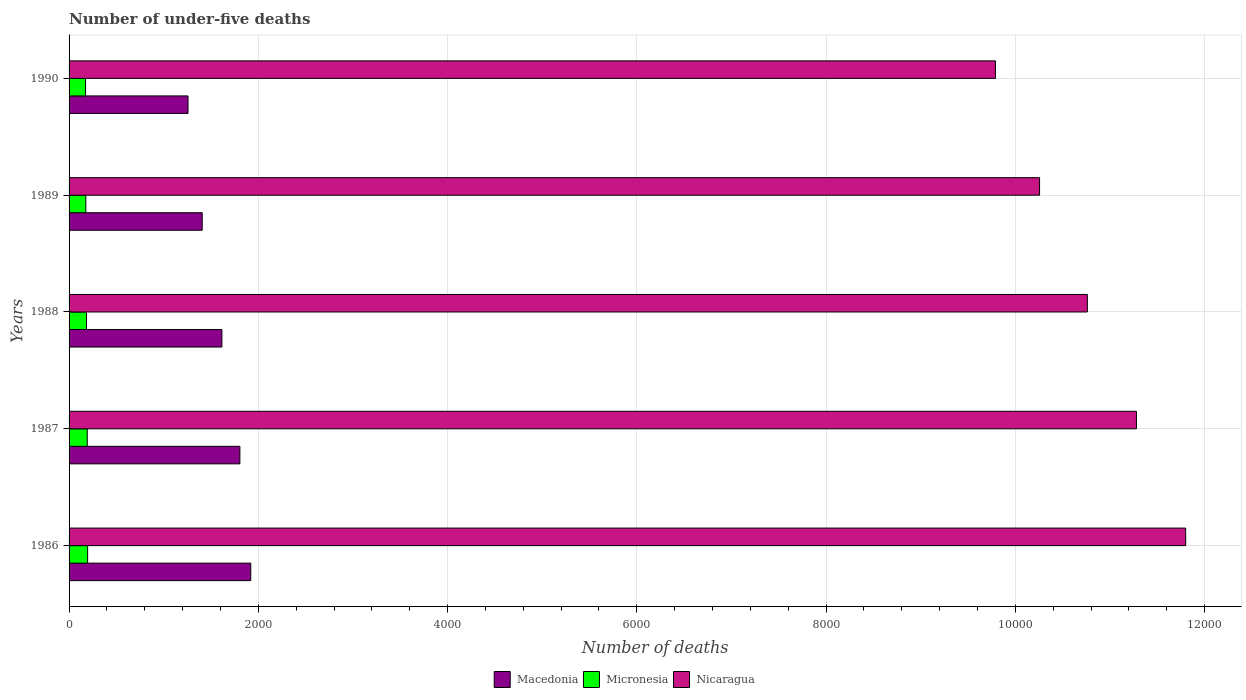How many different coloured bars are there?
Offer a terse response. 3. How many groups of bars are there?
Give a very brief answer. 5. Are the number of bars per tick equal to the number of legend labels?
Provide a succinct answer. Yes. Are the number of bars on each tick of the Y-axis equal?
Offer a terse response. Yes. What is the label of the 4th group of bars from the top?
Your answer should be very brief. 1987. What is the number of under-five deaths in Micronesia in 1986?
Your answer should be compact. 196. Across all years, what is the maximum number of under-five deaths in Nicaragua?
Make the answer very short. 1.18e+04. Across all years, what is the minimum number of under-five deaths in Micronesia?
Offer a terse response. 174. In which year was the number of under-five deaths in Macedonia maximum?
Your answer should be very brief. 1986. What is the total number of under-five deaths in Nicaragua in the graph?
Give a very brief answer. 5.39e+04. What is the difference between the number of under-five deaths in Micronesia in 1988 and that in 1990?
Your answer should be compact. 10. What is the difference between the number of under-five deaths in Macedonia in 1987 and the number of under-five deaths in Nicaragua in 1988?
Provide a succinct answer. -8956. What is the average number of under-five deaths in Nicaragua per year?
Make the answer very short. 1.08e+04. In the year 1989, what is the difference between the number of under-five deaths in Macedonia and number of under-five deaths in Micronesia?
Provide a succinct answer. 1230. In how many years, is the number of under-five deaths in Nicaragua greater than 8800 ?
Your answer should be very brief. 5. What is the ratio of the number of under-five deaths in Macedonia in 1986 to that in 1990?
Ensure brevity in your answer.  1.53. Is the difference between the number of under-five deaths in Macedonia in 1987 and 1990 greater than the difference between the number of under-five deaths in Micronesia in 1987 and 1990?
Ensure brevity in your answer.  Yes. What is the difference between the highest and the second highest number of under-five deaths in Micronesia?
Keep it short and to the point. 4. What is the difference between the highest and the lowest number of under-five deaths in Macedonia?
Offer a very short reply. 663. What does the 3rd bar from the top in 1988 represents?
Keep it short and to the point. Macedonia. What does the 1st bar from the bottom in 1987 represents?
Offer a very short reply. Macedonia. How many bars are there?
Offer a terse response. 15. Are all the bars in the graph horizontal?
Provide a short and direct response. Yes. What is the difference between two consecutive major ticks on the X-axis?
Your answer should be compact. 2000. Are the values on the major ticks of X-axis written in scientific E-notation?
Keep it short and to the point. No. Does the graph contain grids?
Provide a short and direct response. Yes. Where does the legend appear in the graph?
Keep it short and to the point. Bottom center. What is the title of the graph?
Ensure brevity in your answer.  Number of under-five deaths. What is the label or title of the X-axis?
Your response must be concise. Number of deaths. What is the Number of deaths in Macedonia in 1986?
Your answer should be very brief. 1920. What is the Number of deaths in Micronesia in 1986?
Give a very brief answer. 196. What is the Number of deaths in Nicaragua in 1986?
Provide a succinct answer. 1.18e+04. What is the Number of deaths of Macedonia in 1987?
Ensure brevity in your answer.  1805. What is the Number of deaths in Micronesia in 1987?
Keep it short and to the point. 192. What is the Number of deaths in Nicaragua in 1987?
Make the answer very short. 1.13e+04. What is the Number of deaths of Macedonia in 1988?
Offer a terse response. 1615. What is the Number of deaths in Micronesia in 1988?
Give a very brief answer. 184. What is the Number of deaths of Nicaragua in 1988?
Your answer should be very brief. 1.08e+04. What is the Number of deaths in Macedonia in 1989?
Make the answer very short. 1407. What is the Number of deaths of Micronesia in 1989?
Provide a short and direct response. 177. What is the Number of deaths in Nicaragua in 1989?
Make the answer very short. 1.03e+04. What is the Number of deaths of Macedonia in 1990?
Ensure brevity in your answer.  1257. What is the Number of deaths in Micronesia in 1990?
Offer a terse response. 174. What is the Number of deaths of Nicaragua in 1990?
Offer a very short reply. 9790. Across all years, what is the maximum Number of deaths in Macedonia?
Provide a succinct answer. 1920. Across all years, what is the maximum Number of deaths of Micronesia?
Offer a very short reply. 196. Across all years, what is the maximum Number of deaths of Nicaragua?
Your response must be concise. 1.18e+04. Across all years, what is the minimum Number of deaths of Macedonia?
Ensure brevity in your answer.  1257. Across all years, what is the minimum Number of deaths in Micronesia?
Your answer should be very brief. 174. Across all years, what is the minimum Number of deaths of Nicaragua?
Keep it short and to the point. 9790. What is the total Number of deaths in Macedonia in the graph?
Provide a succinct answer. 8004. What is the total Number of deaths in Micronesia in the graph?
Your answer should be compact. 923. What is the total Number of deaths in Nicaragua in the graph?
Keep it short and to the point. 5.39e+04. What is the difference between the Number of deaths of Macedonia in 1986 and that in 1987?
Keep it short and to the point. 115. What is the difference between the Number of deaths in Micronesia in 1986 and that in 1987?
Your answer should be very brief. 4. What is the difference between the Number of deaths in Nicaragua in 1986 and that in 1987?
Your answer should be very brief. 520. What is the difference between the Number of deaths of Macedonia in 1986 and that in 1988?
Provide a short and direct response. 305. What is the difference between the Number of deaths of Micronesia in 1986 and that in 1988?
Offer a terse response. 12. What is the difference between the Number of deaths of Nicaragua in 1986 and that in 1988?
Provide a short and direct response. 1039. What is the difference between the Number of deaths in Macedonia in 1986 and that in 1989?
Provide a short and direct response. 513. What is the difference between the Number of deaths of Micronesia in 1986 and that in 1989?
Keep it short and to the point. 19. What is the difference between the Number of deaths in Nicaragua in 1986 and that in 1989?
Offer a terse response. 1544. What is the difference between the Number of deaths in Macedonia in 1986 and that in 1990?
Your answer should be very brief. 663. What is the difference between the Number of deaths of Nicaragua in 1986 and that in 1990?
Your answer should be very brief. 2010. What is the difference between the Number of deaths in Macedonia in 1987 and that in 1988?
Your answer should be compact. 190. What is the difference between the Number of deaths in Nicaragua in 1987 and that in 1988?
Your answer should be very brief. 519. What is the difference between the Number of deaths of Macedonia in 1987 and that in 1989?
Keep it short and to the point. 398. What is the difference between the Number of deaths in Micronesia in 1987 and that in 1989?
Ensure brevity in your answer.  15. What is the difference between the Number of deaths in Nicaragua in 1987 and that in 1989?
Ensure brevity in your answer.  1024. What is the difference between the Number of deaths of Macedonia in 1987 and that in 1990?
Offer a terse response. 548. What is the difference between the Number of deaths in Micronesia in 1987 and that in 1990?
Offer a very short reply. 18. What is the difference between the Number of deaths in Nicaragua in 1987 and that in 1990?
Provide a succinct answer. 1490. What is the difference between the Number of deaths of Macedonia in 1988 and that in 1989?
Keep it short and to the point. 208. What is the difference between the Number of deaths of Nicaragua in 1988 and that in 1989?
Your response must be concise. 505. What is the difference between the Number of deaths in Macedonia in 1988 and that in 1990?
Make the answer very short. 358. What is the difference between the Number of deaths of Nicaragua in 1988 and that in 1990?
Provide a succinct answer. 971. What is the difference between the Number of deaths in Macedonia in 1989 and that in 1990?
Provide a short and direct response. 150. What is the difference between the Number of deaths in Micronesia in 1989 and that in 1990?
Offer a terse response. 3. What is the difference between the Number of deaths in Nicaragua in 1989 and that in 1990?
Your answer should be compact. 466. What is the difference between the Number of deaths of Macedonia in 1986 and the Number of deaths of Micronesia in 1987?
Give a very brief answer. 1728. What is the difference between the Number of deaths in Macedonia in 1986 and the Number of deaths in Nicaragua in 1987?
Give a very brief answer. -9360. What is the difference between the Number of deaths of Micronesia in 1986 and the Number of deaths of Nicaragua in 1987?
Make the answer very short. -1.11e+04. What is the difference between the Number of deaths in Macedonia in 1986 and the Number of deaths in Micronesia in 1988?
Provide a short and direct response. 1736. What is the difference between the Number of deaths in Macedonia in 1986 and the Number of deaths in Nicaragua in 1988?
Offer a terse response. -8841. What is the difference between the Number of deaths in Micronesia in 1986 and the Number of deaths in Nicaragua in 1988?
Make the answer very short. -1.06e+04. What is the difference between the Number of deaths of Macedonia in 1986 and the Number of deaths of Micronesia in 1989?
Provide a short and direct response. 1743. What is the difference between the Number of deaths of Macedonia in 1986 and the Number of deaths of Nicaragua in 1989?
Ensure brevity in your answer.  -8336. What is the difference between the Number of deaths of Micronesia in 1986 and the Number of deaths of Nicaragua in 1989?
Provide a succinct answer. -1.01e+04. What is the difference between the Number of deaths of Macedonia in 1986 and the Number of deaths of Micronesia in 1990?
Provide a short and direct response. 1746. What is the difference between the Number of deaths in Macedonia in 1986 and the Number of deaths in Nicaragua in 1990?
Offer a very short reply. -7870. What is the difference between the Number of deaths in Micronesia in 1986 and the Number of deaths in Nicaragua in 1990?
Offer a terse response. -9594. What is the difference between the Number of deaths in Macedonia in 1987 and the Number of deaths in Micronesia in 1988?
Keep it short and to the point. 1621. What is the difference between the Number of deaths in Macedonia in 1987 and the Number of deaths in Nicaragua in 1988?
Your response must be concise. -8956. What is the difference between the Number of deaths of Micronesia in 1987 and the Number of deaths of Nicaragua in 1988?
Ensure brevity in your answer.  -1.06e+04. What is the difference between the Number of deaths in Macedonia in 1987 and the Number of deaths in Micronesia in 1989?
Make the answer very short. 1628. What is the difference between the Number of deaths in Macedonia in 1987 and the Number of deaths in Nicaragua in 1989?
Provide a succinct answer. -8451. What is the difference between the Number of deaths of Micronesia in 1987 and the Number of deaths of Nicaragua in 1989?
Keep it short and to the point. -1.01e+04. What is the difference between the Number of deaths in Macedonia in 1987 and the Number of deaths in Micronesia in 1990?
Provide a succinct answer. 1631. What is the difference between the Number of deaths of Macedonia in 1987 and the Number of deaths of Nicaragua in 1990?
Provide a short and direct response. -7985. What is the difference between the Number of deaths of Micronesia in 1987 and the Number of deaths of Nicaragua in 1990?
Your response must be concise. -9598. What is the difference between the Number of deaths of Macedonia in 1988 and the Number of deaths of Micronesia in 1989?
Offer a terse response. 1438. What is the difference between the Number of deaths in Macedonia in 1988 and the Number of deaths in Nicaragua in 1989?
Offer a terse response. -8641. What is the difference between the Number of deaths in Micronesia in 1988 and the Number of deaths in Nicaragua in 1989?
Ensure brevity in your answer.  -1.01e+04. What is the difference between the Number of deaths of Macedonia in 1988 and the Number of deaths of Micronesia in 1990?
Provide a succinct answer. 1441. What is the difference between the Number of deaths of Macedonia in 1988 and the Number of deaths of Nicaragua in 1990?
Your answer should be compact. -8175. What is the difference between the Number of deaths of Micronesia in 1988 and the Number of deaths of Nicaragua in 1990?
Your answer should be compact. -9606. What is the difference between the Number of deaths of Macedonia in 1989 and the Number of deaths of Micronesia in 1990?
Keep it short and to the point. 1233. What is the difference between the Number of deaths in Macedonia in 1989 and the Number of deaths in Nicaragua in 1990?
Keep it short and to the point. -8383. What is the difference between the Number of deaths in Micronesia in 1989 and the Number of deaths in Nicaragua in 1990?
Ensure brevity in your answer.  -9613. What is the average Number of deaths of Macedonia per year?
Ensure brevity in your answer.  1600.8. What is the average Number of deaths in Micronesia per year?
Keep it short and to the point. 184.6. What is the average Number of deaths in Nicaragua per year?
Ensure brevity in your answer.  1.08e+04. In the year 1986, what is the difference between the Number of deaths in Macedonia and Number of deaths in Micronesia?
Ensure brevity in your answer.  1724. In the year 1986, what is the difference between the Number of deaths in Macedonia and Number of deaths in Nicaragua?
Offer a very short reply. -9880. In the year 1986, what is the difference between the Number of deaths of Micronesia and Number of deaths of Nicaragua?
Offer a terse response. -1.16e+04. In the year 1987, what is the difference between the Number of deaths of Macedonia and Number of deaths of Micronesia?
Provide a short and direct response. 1613. In the year 1987, what is the difference between the Number of deaths in Macedonia and Number of deaths in Nicaragua?
Offer a terse response. -9475. In the year 1987, what is the difference between the Number of deaths in Micronesia and Number of deaths in Nicaragua?
Provide a succinct answer. -1.11e+04. In the year 1988, what is the difference between the Number of deaths in Macedonia and Number of deaths in Micronesia?
Give a very brief answer. 1431. In the year 1988, what is the difference between the Number of deaths of Macedonia and Number of deaths of Nicaragua?
Offer a terse response. -9146. In the year 1988, what is the difference between the Number of deaths in Micronesia and Number of deaths in Nicaragua?
Keep it short and to the point. -1.06e+04. In the year 1989, what is the difference between the Number of deaths of Macedonia and Number of deaths of Micronesia?
Provide a short and direct response. 1230. In the year 1989, what is the difference between the Number of deaths of Macedonia and Number of deaths of Nicaragua?
Your response must be concise. -8849. In the year 1989, what is the difference between the Number of deaths in Micronesia and Number of deaths in Nicaragua?
Give a very brief answer. -1.01e+04. In the year 1990, what is the difference between the Number of deaths of Macedonia and Number of deaths of Micronesia?
Ensure brevity in your answer.  1083. In the year 1990, what is the difference between the Number of deaths in Macedonia and Number of deaths in Nicaragua?
Provide a short and direct response. -8533. In the year 1990, what is the difference between the Number of deaths in Micronesia and Number of deaths in Nicaragua?
Keep it short and to the point. -9616. What is the ratio of the Number of deaths in Macedonia in 1986 to that in 1987?
Ensure brevity in your answer.  1.06. What is the ratio of the Number of deaths of Micronesia in 1986 to that in 1987?
Offer a very short reply. 1.02. What is the ratio of the Number of deaths of Nicaragua in 1986 to that in 1987?
Keep it short and to the point. 1.05. What is the ratio of the Number of deaths in Macedonia in 1986 to that in 1988?
Give a very brief answer. 1.19. What is the ratio of the Number of deaths of Micronesia in 1986 to that in 1988?
Give a very brief answer. 1.07. What is the ratio of the Number of deaths of Nicaragua in 1986 to that in 1988?
Offer a very short reply. 1.1. What is the ratio of the Number of deaths in Macedonia in 1986 to that in 1989?
Your response must be concise. 1.36. What is the ratio of the Number of deaths of Micronesia in 1986 to that in 1989?
Keep it short and to the point. 1.11. What is the ratio of the Number of deaths in Nicaragua in 1986 to that in 1989?
Keep it short and to the point. 1.15. What is the ratio of the Number of deaths in Macedonia in 1986 to that in 1990?
Your response must be concise. 1.53. What is the ratio of the Number of deaths in Micronesia in 1986 to that in 1990?
Keep it short and to the point. 1.13. What is the ratio of the Number of deaths of Nicaragua in 1986 to that in 1990?
Provide a short and direct response. 1.21. What is the ratio of the Number of deaths in Macedonia in 1987 to that in 1988?
Provide a succinct answer. 1.12. What is the ratio of the Number of deaths of Micronesia in 1987 to that in 1988?
Provide a succinct answer. 1.04. What is the ratio of the Number of deaths in Nicaragua in 1987 to that in 1988?
Keep it short and to the point. 1.05. What is the ratio of the Number of deaths of Macedonia in 1987 to that in 1989?
Give a very brief answer. 1.28. What is the ratio of the Number of deaths in Micronesia in 1987 to that in 1989?
Give a very brief answer. 1.08. What is the ratio of the Number of deaths in Nicaragua in 1987 to that in 1989?
Offer a terse response. 1.1. What is the ratio of the Number of deaths in Macedonia in 1987 to that in 1990?
Your answer should be compact. 1.44. What is the ratio of the Number of deaths in Micronesia in 1987 to that in 1990?
Your answer should be compact. 1.1. What is the ratio of the Number of deaths of Nicaragua in 1987 to that in 1990?
Give a very brief answer. 1.15. What is the ratio of the Number of deaths in Macedonia in 1988 to that in 1989?
Offer a very short reply. 1.15. What is the ratio of the Number of deaths in Micronesia in 1988 to that in 1989?
Your response must be concise. 1.04. What is the ratio of the Number of deaths of Nicaragua in 1988 to that in 1989?
Offer a terse response. 1.05. What is the ratio of the Number of deaths of Macedonia in 1988 to that in 1990?
Ensure brevity in your answer.  1.28. What is the ratio of the Number of deaths in Micronesia in 1988 to that in 1990?
Offer a very short reply. 1.06. What is the ratio of the Number of deaths of Nicaragua in 1988 to that in 1990?
Provide a short and direct response. 1.1. What is the ratio of the Number of deaths of Macedonia in 1989 to that in 1990?
Make the answer very short. 1.12. What is the ratio of the Number of deaths of Micronesia in 1989 to that in 1990?
Your answer should be very brief. 1.02. What is the ratio of the Number of deaths in Nicaragua in 1989 to that in 1990?
Your answer should be very brief. 1.05. What is the difference between the highest and the second highest Number of deaths in Macedonia?
Your answer should be compact. 115. What is the difference between the highest and the second highest Number of deaths in Nicaragua?
Your response must be concise. 520. What is the difference between the highest and the lowest Number of deaths in Macedonia?
Offer a terse response. 663. What is the difference between the highest and the lowest Number of deaths in Nicaragua?
Your answer should be compact. 2010. 